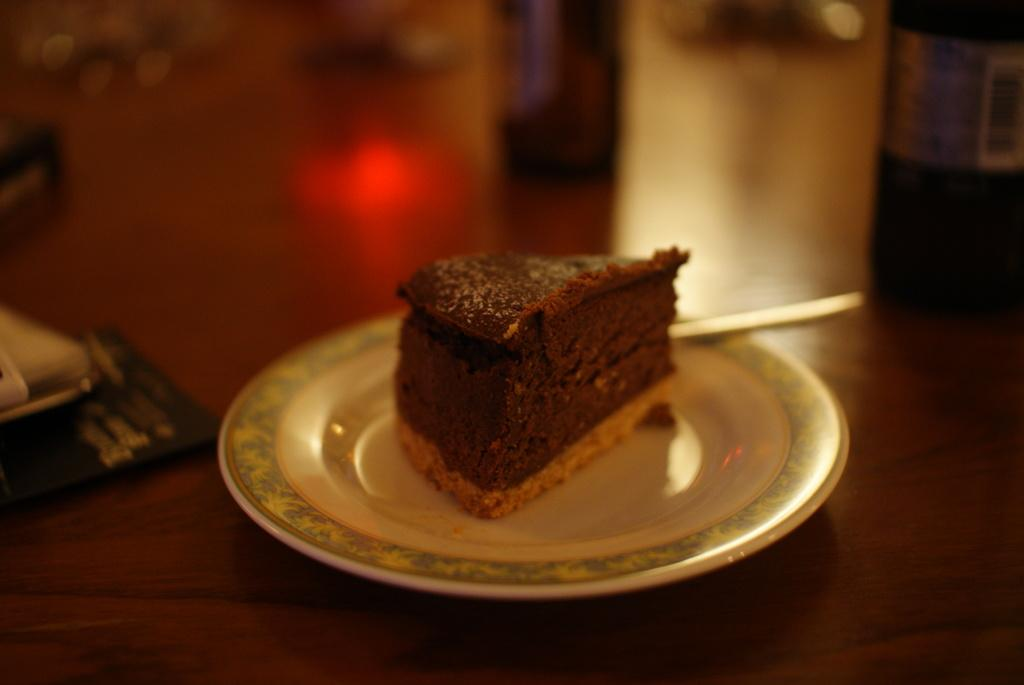What is on the plate that is visible in the image? There is a piece of cake on the plate. What type of surface is the plate resting on? There is a wooden surface in the image. How would you describe the background of the image? The background of the image is blurred. How many toes can be seen in the image? There are no toes visible in the image. What type of health advice is being given in the image? There is no health advice present in the image. Is there a baseball game happening in the image? There is no baseball game or any reference to baseball in the image. 